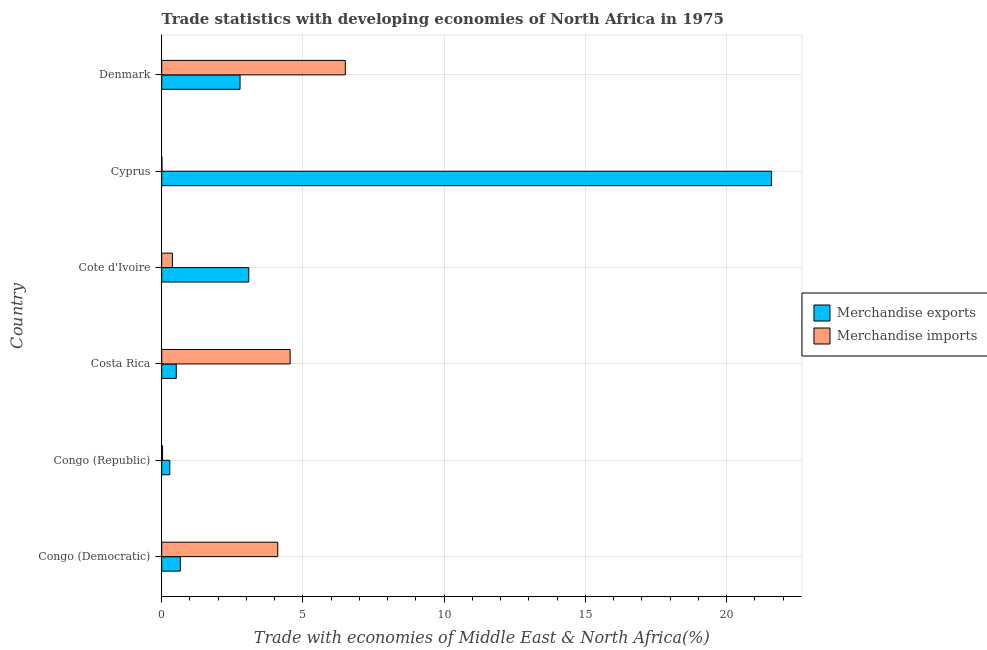How many different coloured bars are there?
Provide a short and direct response. 2. How many groups of bars are there?
Make the answer very short. 6. How many bars are there on the 6th tick from the bottom?
Keep it short and to the point. 2. What is the label of the 4th group of bars from the top?
Your answer should be very brief. Costa Rica. In how many cases, is the number of bars for a given country not equal to the number of legend labels?
Make the answer very short. 0. What is the merchandise imports in Costa Rica?
Provide a short and direct response. 4.55. Across all countries, what is the maximum merchandise exports?
Your response must be concise. 21.58. Across all countries, what is the minimum merchandise imports?
Keep it short and to the point. 0.01. In which country was the merchandise imports minimum?
Make the answer very short. Cyprus. What is the total merchandise imports in the graph?
Your answer should be very brief. 15.57. What is the difference between the merchandise exports in Congo (Republic) and that in Cyprus?
Make the answer very short. -21.3. What is the difference between the merchandise imports in Costa Rica and the merchandise exports in Cyprus?
Make the answer very short. -17.04. What is the average merchandise imports per country?
Your answer should be very brief. 2.6. What is the difference between the merchandise exports and merchandise imports in Congo (Democratic)?
Offer a terse response. -3.45. In how many countries, is the merchandise imports greater than 14 %?
Your response must be concise. 0. What is the ratio of the merchandise imports in Congo (Republic) to that in Cote d'Ivoire?
Your answer should be very brief. 0.08. Is the merchandise imports in Costa Rica less than that in Cyprus?
Offer a very short reply. No. Is the difference between the merchandise imports in Cote d'Ivoire and Cyprus greater than the difference between the merchandise exports in Cote d'Ivoire and Cyprus?
Your response must be concise. Yes. What is the difference between the highest and the second highest merchandise exports?
Your answer should be compact. 18.5. What is the difference between the highest and the lowest merchandise exports?
Provide a succinct answer. 21.3. Is the sum of the merchandise exports in Congo (Democratic) and Costa Rica greater than the maximum merchandise imports across all countries?
Keep it short and to the point. No. What does the 1st bar from the top in Cote d'Ivoire represents?
Make the answer very short. Merchandise imports. Are all the bars in the graph horizontal?
Ensure brevity in your answer.  Yes. How many countries are there in the graph?
Ensure brevity in your answer.  6. Does the graph contain any zero values?
Provide a succinct answer. No. Does the graph contain grids?
Ensure brevity in your answer.  Yes. Where does the legend appear in the graph?
Make the answer very short. Center right. How are the legend labels stacked?
Keep it short and to the point. Vertical. What is the title of the graph?
Offer a terse response. Trade statistics with developing economies of North Africa in 1975. Does "GDP at market prices" appear as one of the legend labels in the graph?
Ensure brevity in your answer.  No. What is the label or title of the X-axis?
Make the answer very short. Trade with economies of Middle East & North Africa(%). What is the label or title of the Y-axis?
Your answer should be very brief. Country. What is the Trade with economies of Middle East & North Africa(%) in Merchandise exports in Congo (Democratic)?
Keep it short and to the point. 0.66. What is the Trade with economies of Middle East & North Africa(%) of Merchandise imports in Congo (Democratic)?
Give a very brief answer. 4.11. What is the Trade with economies of Middle East & North Africa(%) of Merchandise exports in Congo (Republic)?
Offer a terse response. 0.29. What is the Trade with economies of Middle East & North Africa(%) in Merchandise imports in Congo (Republic)?
Offer a terse response. 0.03. What is the Trade with economies of Middle East & North Africa(%) in Merchandise exports in Costa Rica?
Provide a succinct answer. 0.52. What is the Trade with economies of Middle East & North Africa(%) of Merchandise imports in Costa Rica?
Your response must be concise. 4.55. What is the Trade with economies of Middle East & North Africa(%) in Merchandise exports in Cote d'Ivoire?
Provide a short and direct response. 3.08. What is the Trade with economies of Middle East & North Africa(%) of Merchandise imports in Cote d'Ivoire?
Your answer should be very brief. 0.38. What is the Trade with economies of Middle East & North Africa(%) of Merchandise exports in Cyprus?
Your answer should be very brief. 21.58. What is the Trade with economies of Middle East & North Africa(%) in Merchandise imports in Cyprus?
Offer a very short reply. 0.01. What is the Trade with economies of Middle East & North Africa(%) in Merchandise exports in Denmark?
Your response must be concise. 2.77. What is the Trade with economies of Middle East & North Africa(%) in Merchandise imports in Denmark?
Offer a terse response. 6.5. Across all countries, what is the maximum Trade with economies of Middle East & North Africa(%) of Merchandise exports?
Make the answer very short. 21.58. Across all countries, what is the maximum Trade with economies of Middle East & North Africa(%) of Merchandise imports?
Offer a terse response. 6.5. Across all countries, what is the minimum Trade with economies of Middle East & North Africa(%) of Merchandise exports?
Ensure brevity in your answer.  0.29. Across all countries, what is the minimum Trade with economies of Middle East & North Africa(%) in Merchandise imports?
Your response must be concise. 0.01. What is the total Trade with economies of Middle East & North Africa(%) in Merchandise exports in the graph?
Provide a short and direct response. 28.9. What is the total Trade with economies of Middle East & North Africa(%) of Merchandise imports in the graph?
Keep it short and to the point. 15.57. What is the difference between the Trade with economies of Middle East & North Africa(%) of Merchandise exports in Congo (Democratic) and that in Congo (Republic)?
Give a very brief answer. 0.37. What is the difference between the Trade with economies of Middle East & North Africa(%) of Merchandise imports in Congo (Democratic) and that in Congo (Republic)?
Your answer should be very brief. 4.08. What is the difference between the Trade with economies of Middle East & North Africa(%) in Merchandise exports in Congo (Democratic) and that in Costa Rica?
Make the answer very short. 0.14. What is the difference between the Trade with economies of Middle East & North Africa(%) in Merchandise imports in Congo (Democratic) and that in Costa Rica?
Your response must be concise. -0.44. What is the difference between the Trade with economies of Middle East & North Africa(%) of Merchandise exports in Congo (Democratic) and that in Cote d'Ivoire?
Provide a short and direct response. -2.42. What is the difference between the Trade with economies of Middle East & North Africa(%) of Merchandise imports in Congo (Democratic) and that in Cote d'Ivoire?
Your response must be concise. 3.73. What is the difference between the Trade with economies of Middle East & North Africa(%) in Merchandise exports in Congo (Democratic) and that in Cyprus?
Give a very brief answer. -20.93. What is the difference between the Trade with economies of Middle East & North Africa(%) in Merchandise imports in Congo (Democratic) and that in Cyprus?
Provide a short and direct response. 4.1. What is the difference between the Trade with economies of Middle East & North Africa(%) in Merchandise exports in Congo (Democratic) and that in Denmark?
Your answer should be very brief. -2.11. What is the difference between the Trade with economies of Middle East & North Africa(%) in Merchandise imports in Congo (Democratic) and that in Denmark?
Your answer should be very brief. -2.39. What is the difference between the Trade with economies of Middle East & North Africa(%) of Merchandise exports in Congo (Republic) and that in Costa Rica?
Keep it short and to the point. -0.23. What is the difference between the Trade with economies of Middle East & North Africa(%) in Merchandise imports in Congo (Republic) and that in Costa Rica?
Offer a terse response. -4.51. What is the difference between the Trade with economies of Middle East & North Africa(%) of Merchandise exports in Congo (Republic) and that in Cote d'Ivoire?
Your answer should be very brief. -2.79. What is the difference between the Trade with economies of Middle East & North Africa(%) of Merchandise imports in Congo (Republic) and that in Cote d'Ivoire?
Provide a short and direct response. -0.35. What is the difference between the Trade with economies of Middle East & North Africa(%) of Merchandise exports in Congo (Republic) and that in Cyprus?
Give a very brief answer. -21.3. What is the difference between the Trade with economies of Middle East & North Africa(%) of Merchandise imports in Congo (Republic) and that in Cyprus?
Offer a terse response. 0.02. What is the difference between the Trade with economies of Middle East & North Africa(%) in Merchandise exports in Congo (Republic) and that in Denmark?
Your answer should be very brief. -2.49. What is the difference between the Trade with economies of Middle East & North Africa(%) of Merchandise imports in Congo (Republic) and that in Denmark?
Your answer should be compact. -6.47. What is the difference between the Trade with economies of Middle East & North Africa(%) in Merchandise exports in Costa Rica and that in Cote d'Ivoire?
Your answer should be very brief. -2.57. What is the difference between the Trade with economies of Middle East & North Africa(%) in Merchandise imports in Costa Rica and that in Cote d'Ivoire?
Make the answer very short. 4.17. What is the difference between the Trade with economies of Middle East & North Africa(%) of Merchandise exports in Costa Rica and that in Cyprus?
Your answer should be compact. -21.07. What is the difference between the Trade with economies of Middle East & North Africa(%) of Merchandise imports in Costa Rica and that in Cyprus?
Provide a short and direct response. 4.54. What is the difference between the Trade with economies of Middle East & North Africa(%) of Merchandise exports in Costa Rica and that in Denmark?
Make the answer very short. -2.26. What is the difference between the Trade with economies of Middle East & North Africa(%) in Merchandise imports in Costa Rica and that in Denmark?
Your response must be concise. -1.95. What is the difference between the Trade with economies of Middle East & North Africa(%) of Merchandise exports in Cote d'Ivoire and that in Cyprus?
Make the answer very short. -18.5. What is the difference between the Trade with economies of Middle East & North Africa(%) in Merchandise imports in Cote d'Ivoire and that in Cyprus?
Offer a very short reply. 0.37. What is the difference between the Trade with economies of Middle East & North Africa(%) of Merchandise exports in Cote d'Ivoire and that in Denmark?
Your response must be concise. 0.31. What is the difference between the Trade with economies of Middle East & North Africa(%) in Merchandise imports in Cote d'Ivoire and that in Denmark?
Give a very brief answer. -6.12. What is the difference between the Trade with economies of Middle East & North Africa(%) of Merchandise exports in Cyprus and that in Denmark?
Ensure brevity in your answer.  18.81. What is the difference between the Trade with economies of Middle East & North Africa(%) in Merchandise imports in Cyprus and that in Denmark?
Your response must be concise. -6.49. What is the difference between the Trade with economies of Middle East & North Africa(%) in Merchandise exports in Congo (Democratic) and the Trade with economies of Middle East & North Africa(%) in Merchandise imports in Congo (Republic)?
Provide a short and direct response. 0.63. What is the difference between the Trade with economies of Middle East & North Africa(%) of Merchandise exports in Congo (Democratic) and the Trade with economies of Middle East & North Africa(%) of Merchandise imports in Costa Rica?
Your response must be concise. -3.89. What is the difference between the Trade with economies of Middle East & North Africa(%) of Merchandise exports in Congo (Democratic) and the Trade with economies of Middle East & North Africa(%) of Merchandise imports in Cote d'Ivoire?
Give a very brief answer. 0.28. What is the difference between the Trade with economies of Middle East & North Africa(%) in Merchandise exports in Congo (Democratic) and the Trade with economies of Middle East & North Africa(%) in Merchandise imports in Cyprus?
Keep it short and to the point. 0.65. What is the difference between the Trade with economies of Middle East & North Africa(%) in Merchandise exports in Congo (Democratic) and the Trade with economies of Middle East & North Africa(%) in Merchandise imports in Denmark?
Your answer should be compact. -5.84. What is the difference between the Trade with economies of Middle East & North Africa(%) in Merchandise exports in Congo (Republic) and the Trade with economies of Middle East & North Africa(%) in Merchandise imports in Costa Rica?
Make the answer very short. -4.26. What is the difference between the Trade with economies of Middle East & North Africa(%) of Merchandise exports in Congo (Republic) and the Trade with economies of Middle East & North Africa(%) of Merchandise imports in Cote d'Ivoire?
Offer a very short reply. -0.09. What is the difference between the Trade with economies of Middle East & North Africa(%) of Merchandise exports in Congo (Republic) and the Trade with economies of Middle East & North Africa(%) of Merchandise imports in Cyprus?
Your answer should be very brief. 0.28. What is the difference between the Trade with economies of Middle East & North Africa(%) in Merchandise exports in Congo (Republic) and the Trade with economies of Middle East & North Africa(%) in Merchandise imports in Denmark?
Provide a succinct answer. -6.21. What is the difference between the Trade with economies of Middle East & North Africa(%) of Merchandise exports in Costa Rica and the Trade with economies of Middle East & North Africa(%) of Merchandise imports in Cote d'Ivoire?
Keep it short and to the point. 0.14. What is the difference between the Trade with economies of Middle East & North Africa(%) in Merchandise exports in Costa Rica and the Trade with economies of Middle East & North Africa(%) in Merchandise imports in Cyprus?
Make the answer very short. 0.51. What is the difference between the Trade with economies of Middle East & North Africa(%) in Merchandise exports in Costa Rica and the Trade with economies of Middle East & North Africa(%) in Merchandise imports in Denmark?
Offer a terse response. -5.98. What is the difference between the Trade with economies of Middle East & North Africa(%) in Merchandise exports in Cote d'Ivoire and the Trade with economies of Middle East & North Africa(%) in Merchandise imports in Cyprus?
Provide a succinct answer. 3.07. What is the difference between the Trade with economies of Middle East & North Africa(%) of Merchandise exports in Cote d'Ivoire and the Trade with economies of Middle East & North Africa(%) of Merchandise imports in Denmark?
Make the answer very short. -3.42. What is the difference between the Trade with economies of Middle East & North Africa(%) in Merchandise exports in Cyprus and the Trade with economies of Middle East & North Africa(%) in Merchandise imports in Denmark?
Ensure brevity in your answer.  15.09. What is the average Trade with economies of Middle East & North Africa(%) in Merchandise exports per country?
Make the answer very short. 4.82. What is the average Trade with economies of Middle East & North Africa(%) in Merchandise imports per country?
Ensure brevity in your answer.  2.6. What is the difference between the Trade with economies of Middle East & North Africa(%) of Merchandise exports and Trade with economies of Middle East & North Africa(%) of Merchandise imports in Congo (Democratic)?
Your answer should be very brief. -3.45. What is the difference between the Trade with economies of Middle East & North Africa(%) in Merchandise exports and Trade with economies of Middle East & North Africa(%) in Merchandise imports in Congo (Republic)?
Provide a short and direct response. 0.26. What is the difference between the Trade with economies of Middle East & North Africa(%) in Merchandise exports and Trade with economies of Middle East & North Africa(%) in Merchandise imports in Costa Rica?
Your answer should be compact. -4.03. What is the difference between the Trade with economies of Middle East & North Africa(%) of Merchandise exports and Trade with economies of Middle East & North Africa(%) of Merchandise imports in Cote d'Ivoire?
Your response must be concise. 2.7. What is the difference between the Trade with economies of Middle East & North Africa(%) in Merchandise exports and Trade with economies of Middle East & North Africa(%) in Merchandise imports in Cyprus?
Provide a succinct answer. 21.58. What is the difference between the Trade with economies of Middle East & North Africa(%) in Merchandise exports and Trade with economies of Middle East & North Africa(%) in Merchandise imports in Denmark?
Make the answer very short. -3.73. What is the ratio of the Trade with economies of Middle East & North Africa(%) in Merchandise exports in Congo (Democratic) to that in Congo (Republic)?
Your response must be concise. 2.3. What is the ratio of the Trade with economies of Middle East & North Africa(%) of Merchandise imports in Congo (Democratic) to that in Congo (Republic)?
Give a very brief answer. 130.66. What is the ratio of the Trade with economies of Middle East & North Africa(%) in Merchandise exports in Congo (Democratic) to that in Costa Rica?
Your response must be concise. 1.28. What is the ratio of the Trade with economies of Middle East & North Africa(%) of Merchandise imports in Congo (Democratic) to that in Costa Rica?
Offer a terse response. 0.9. What is the ratio of the Trade with economies of Middle East & North Africa(%) of Merchandise exports in Congo (Democratic) to that in Cote d'Ivoire?
Your answer should be compact. 0.21. What is the ratio of the Trade with economies of Middle East & North Africa(%) of Merchandise imports in Congo (Democratic) to that in Cote d'Ivoire?
Give a very brief answer. 10.87. What is the ratio of the Trade with economies of Middle East & North Africa(%) of Merchandise exports in Congo (Democratic) to that in Cyprus?
Offer a very short reply. 0.03. What is the ratio of the Trade with economies of Middle East & North Africa(%) in Merchandise imports in Congo (Democratic) to that in Cyprus?
Offer a very short reply. 474.64. What is the ratio of the Trade with economies of Middle East & North Africa(%) of Merchandise exports in Congo (Democratic) to that in Denmark?
Offer a very short reply. 0.24. What is the ratio of the Trade with economies of Middle East & North Africa(%) of Merchandise imports in Congo (Democratic) to that in Denmark?
Ensure brevity in your answer.  0.63. What is the ratio of the Trade with economies of Middle East & North Africa(%) in Merchandise exports in Congo (Republic) to that in Costa Rica?
Give a very brief answer. 0.56. What is the ratio of the Trade with economies of Middle East & North Africa(%) in Merchandise imports in Congo (Republic) to that in Costa Rica?
Ensure brevity in your answer.  0.01. What is the ratio of the Trade with economies of Middle East & North Africa(%) of Merchandise exports in Congo (Republic) to that in Cote d'Ivoire?
Offer a terse response. 0.09. What is the ratio of the Trade with economies of Middle East & North Africa(%) of Merchandise imports in Congo (Republic) to that in Cote d'Ivoire?
Give a very brief answer. 0.08. What is the ratio of the Trade with economies of Middle East & North Africa(%) of Merchandise exports in Congo (Republic) to that in Cyprus?
Give a very brief answer. 0.01. What is the ratio of the Trade with economies of Middle East & North Africa(%) of Merchandise imports in Congo (Republic) to that in Cyprus?
Your answer should be very brief. 3.63. What is the ratio of the Trade with economies of Middle East & North Africa(%) in Merchandise exports in Congo (Republic) to that in Denmark?
Make the answer very short. 0.1. What is the ratio of the Trade with economies of Middle East & North Africa(%) of Merchandise imports in Congo (Republic) to that in Denmark?
Keep it short and to the point. 0. What is the ratio of the Trade with economies of Middle East & North Africa(%) of Merchandise exports in Costa Rica to that in Cote d'Ivoire?
Provide a succinct answer. 0.17. What is the ratio of the Trade with economies of Middle East & North Africa(%) of Merchandise imports in Costa Rica to that in Cote d'Ivoire?
Keep it short and to the point. 12.02. What is the ratio of the Trade with economies of Middle East & North Africa(%) of Merchandise exports in Costa Rica to that in Cyprus?
Provide a short and direct response. 0.02. What is the ratio of the Trade with economies of Middle East & North Africa(%) of Merchandise imports in Costa Rica to that in Cyprus?
Your answer should be very brief. 525.15. What is the ratio of the Trade with economies of Middle East & North Africa(%) of Merchandise exports in Costa Rica to that in Denmark?
Provide a short and direct response. 0.19. What is the ratio of the Trade with economies of Middle East & North Africa(%) in Merchandise imports in Costa Rica to that in Denmark?
Make the answer very short. 0.7. What is the ratio of the Trade with economies of Middle East & North Africa(%) in Merchandise exports in Cote d'Ivoire to that in Cyprus?
Keep it short and to the point. 0.14. What is the ratio of the Trade with economies of Middle East & North Africa(%) in Merchandise imports in Cote d'Ivoire to that in Cyprus?
Offer a terse response. 43.67. What is the ratio of the Trade with economies of Middle East & North Africa(%) in Merchandise exports in Cote d'Ivoire to that in Denmark?
Provide a succinct answer. 1.11. What is the ratio of the Trade with economies of Middle East & North Africa(%) in Merchandise imports in Cote d'Ivoire to that in Denmark?
Your answer should be compact. 0.06. What is the ratio of the Trade with economies of Middle East & North Africa(%) of Merchandise exports in Cyprus to that in Denmark?
Your response must be concise. 7.78. What is the ratio of the Trade with economies of Middle East & North Africa(%) in Merchandise imports in Cyprus to that in Denmark?
Provide a short and direct response. 0. What is the difference between the highest and the second highest Trade with economies of Middle East & North Africa(%) of Merchandise exports?
Make the answer very short. 18.5. What is the difference between the highest and the second highest Trade with economies of Middle East & North Africa(%) in Merchandise imports?
Your response must be concise. 1.95. What is the difference between the highest and the lowest Trade with economies of Middle East & North Africa(%) of Merchandise exports?
Give a very brief answer. 21.3. What is the difference between the highest and the lowest Trade with economies of Middle East & North Africa(%) of Merchandise imports?
Provide a succinct answer. 6.49. 